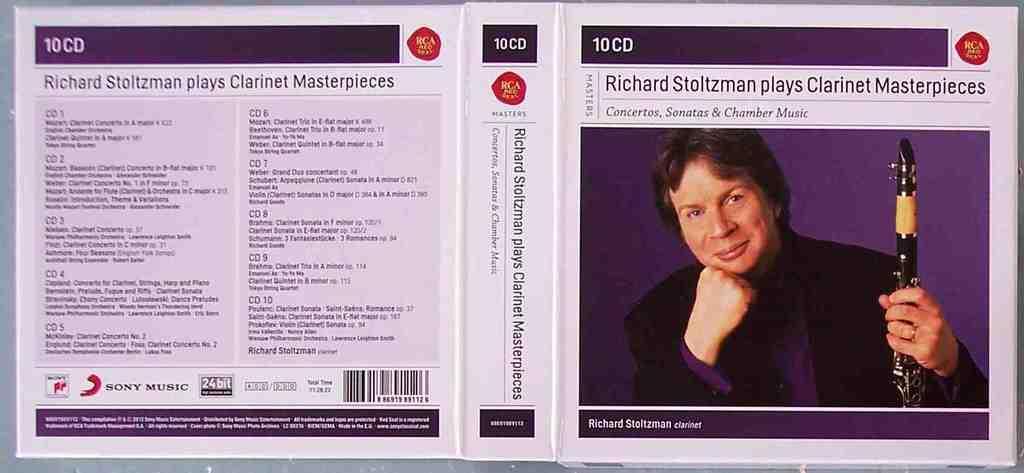In one or two sentences, can you explain what this image depicts? Here in this picture we can see cover page of a CD and in that on the right side we can see a person present and he is holding a musical instrument and smiling and we can also see some text present on left side. 